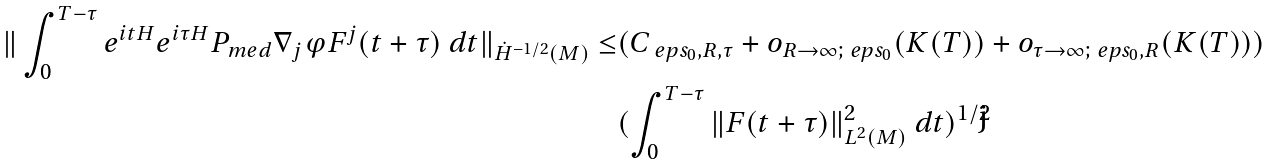<formula> <loc_0><loc_0><loc_500><loc_500>\| \int _ { 0 } ^ { T - \tau } e ^ { i t H } e ^ { i \tau H } P _ { m e d } \nabla _ { j } \varphi F ^ { j } ( t + \tau ) \ d t \| _ { \dot { H } ^ { - 1 / 2 } ( M ) } \leq & ( C _ { \ e p s _ { 0 } , R , \tau } + o _ { R \to \infty ; \ e p s _ { 0 } } ( K ( T ) ) + o _ { \tau \to \infty ; \ e p s _ { 0 } , R } ( K ( T ) ) ) \\ & ( \int _ { 0 } ^ { T - \tau } \| F ( t + \tau ) \| _ { L ^ { 2 } ( M ) } ^ { 2 } \ d t ) ^ { 1 / 2 }</formula> 